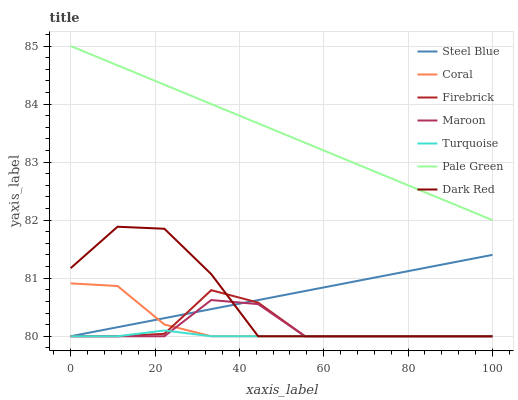Does Turquoise have the minimum area under the curve?
Answer yes or no. Yes. Does Pale Green have the maximum area under the curve?
Answer yes or no. Yes. Does Dark Red have the minimum area under the curve?
Answer yes or no. No. Does Dark Red have the maximum area under the curve?
Answer yes or no. No. Is Pale Green the smoothest?
Answer yes or no. Yes. Is Dark Red the roughest?
Answer yes or no. Yes. Is Firebrick the smoothest?
Answer yes or no. No. Is Firebrick the roughest?
Answer yes or no. No. Does Turquoise have the lowest value?
Answer yes or no. Yes. Does Pale Green have the lowest value?
Answer yes or no. No. Does Pale Green have the highest value?
Answer yes or no. Yes. Does Dark Red have the highest value?
Answer yes or no. No. Is Turquoise less than Pale Green?
Answer yes or no. Yes. Is Pale Green greater than Maroon?
Answer yes or no. Yes. Does Dark Red intersect Coral?
Answer yes or no. Yes. Is Dark Red less than Coral?
Answer yes or no. No. Is Dark Red greater than Coral?
Answer yes or no. No. Does Turquoise intersect Pale Green?
Answer yes or no. No. 